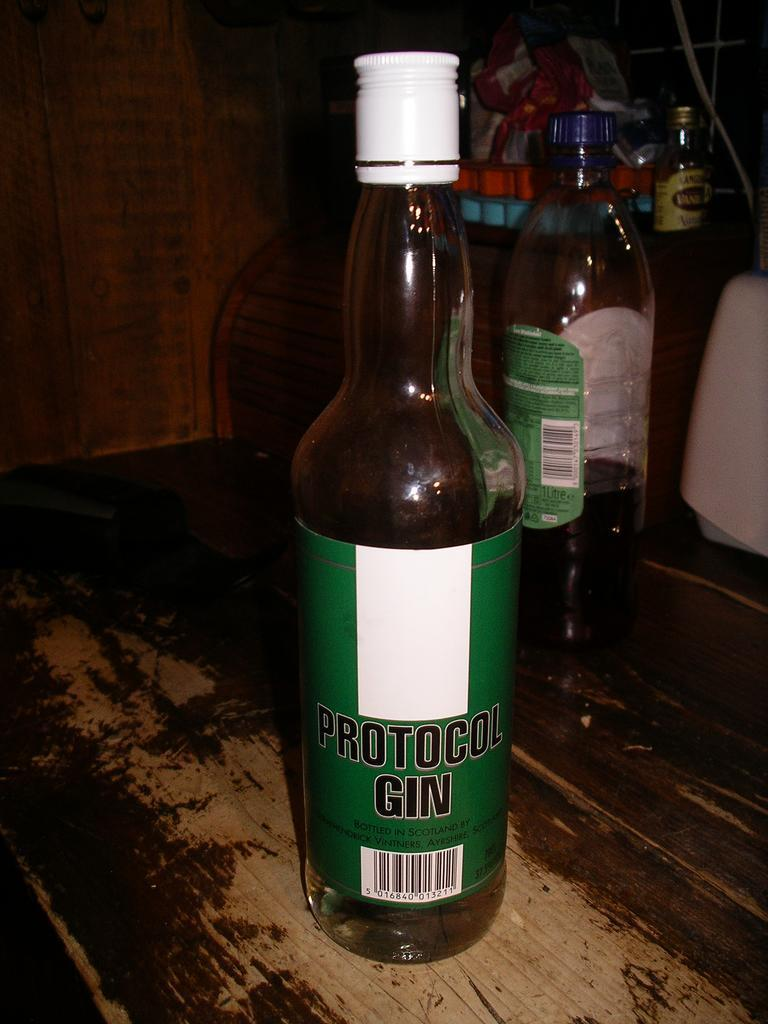<image>
Provide a brief description of the given image. A bottle of Protocol Gin standing in front of two other bottles. 